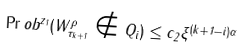<formula> <loc_0><loc_0><loc_500><loc_500>\Pr o b ^ { z _ { 1 } } ( W ^ { \rho } _ { \tau _ { k + 1 } } \notin Q _ { i } ) \leq c _ { 2 } \xi ^ { ( k + 1 - i ) \alpha }</formula> 